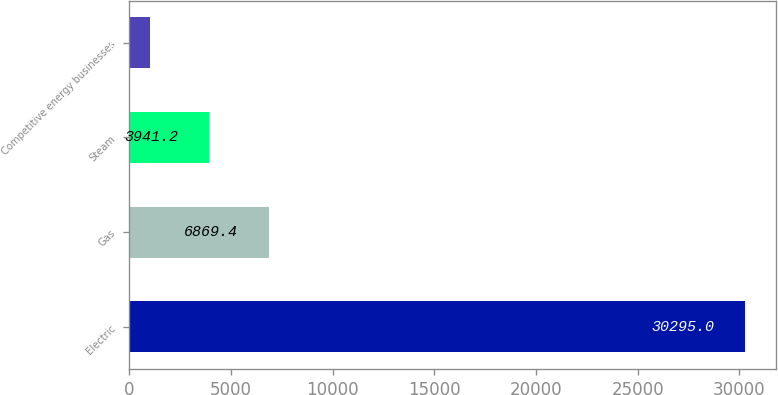Convert chart to OTSL. <chart><loc_0><loc_0><loc_500><loc_500><bar_chart><fcel>Electric<fcel>Gas<fcel>Steam<fcel>Competitive energy businesses<nl><fcel>30295<fcel>6869.4<fcel>3941.2<fcel>1013<nl></chart> 